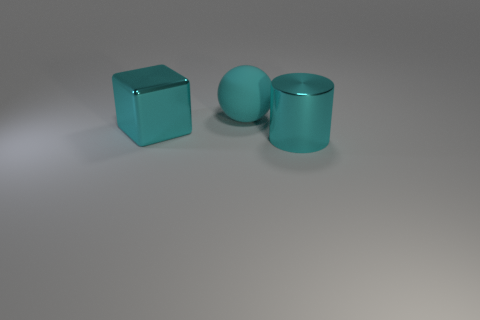What is the relative size of these objects in comparison to each other? The objects, consisting of the cube, sphere, and cylinder, seem to have quite similar dimensions in terms of height and width. While the cube has equal measurements on all sides, the sphere diameter and cylinder height and diameter appear to be slightly smaller than the cube's edge length, suggesting a harmonious and calculated placement in relation to one another. 